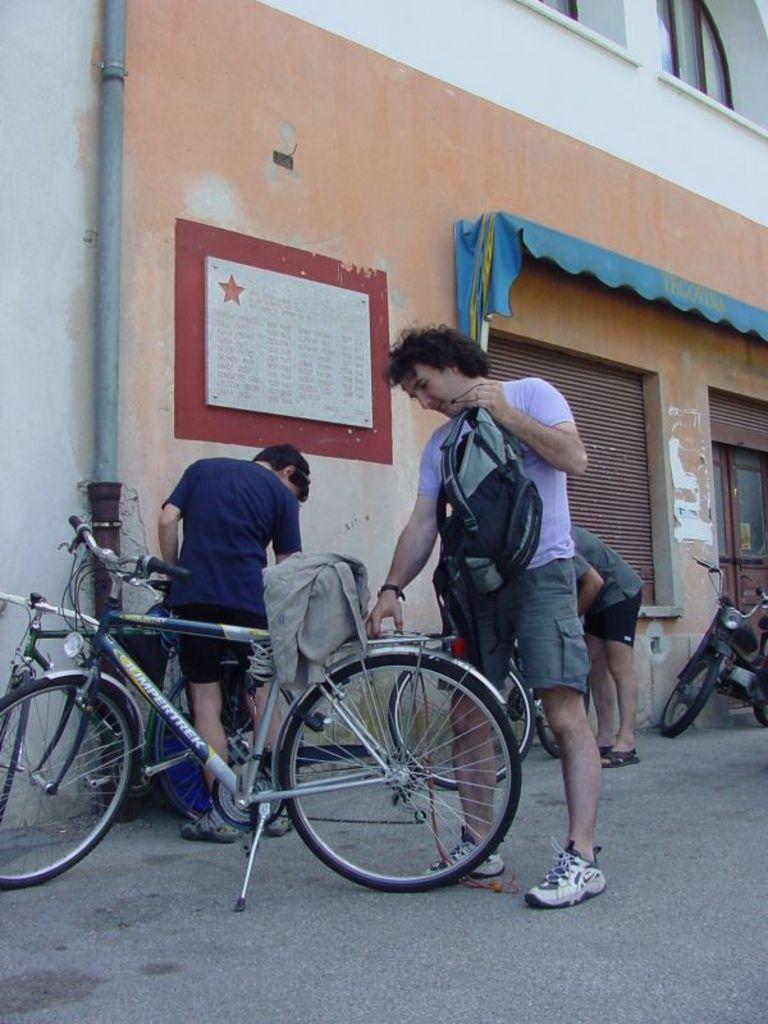How would you summarize this image in a sentence or two? In this image we can see persons, bicycles, bags and other objects. In the background of the image there is a building, name board, vehicle and other objects. At the bottom of the image there is the floor. 